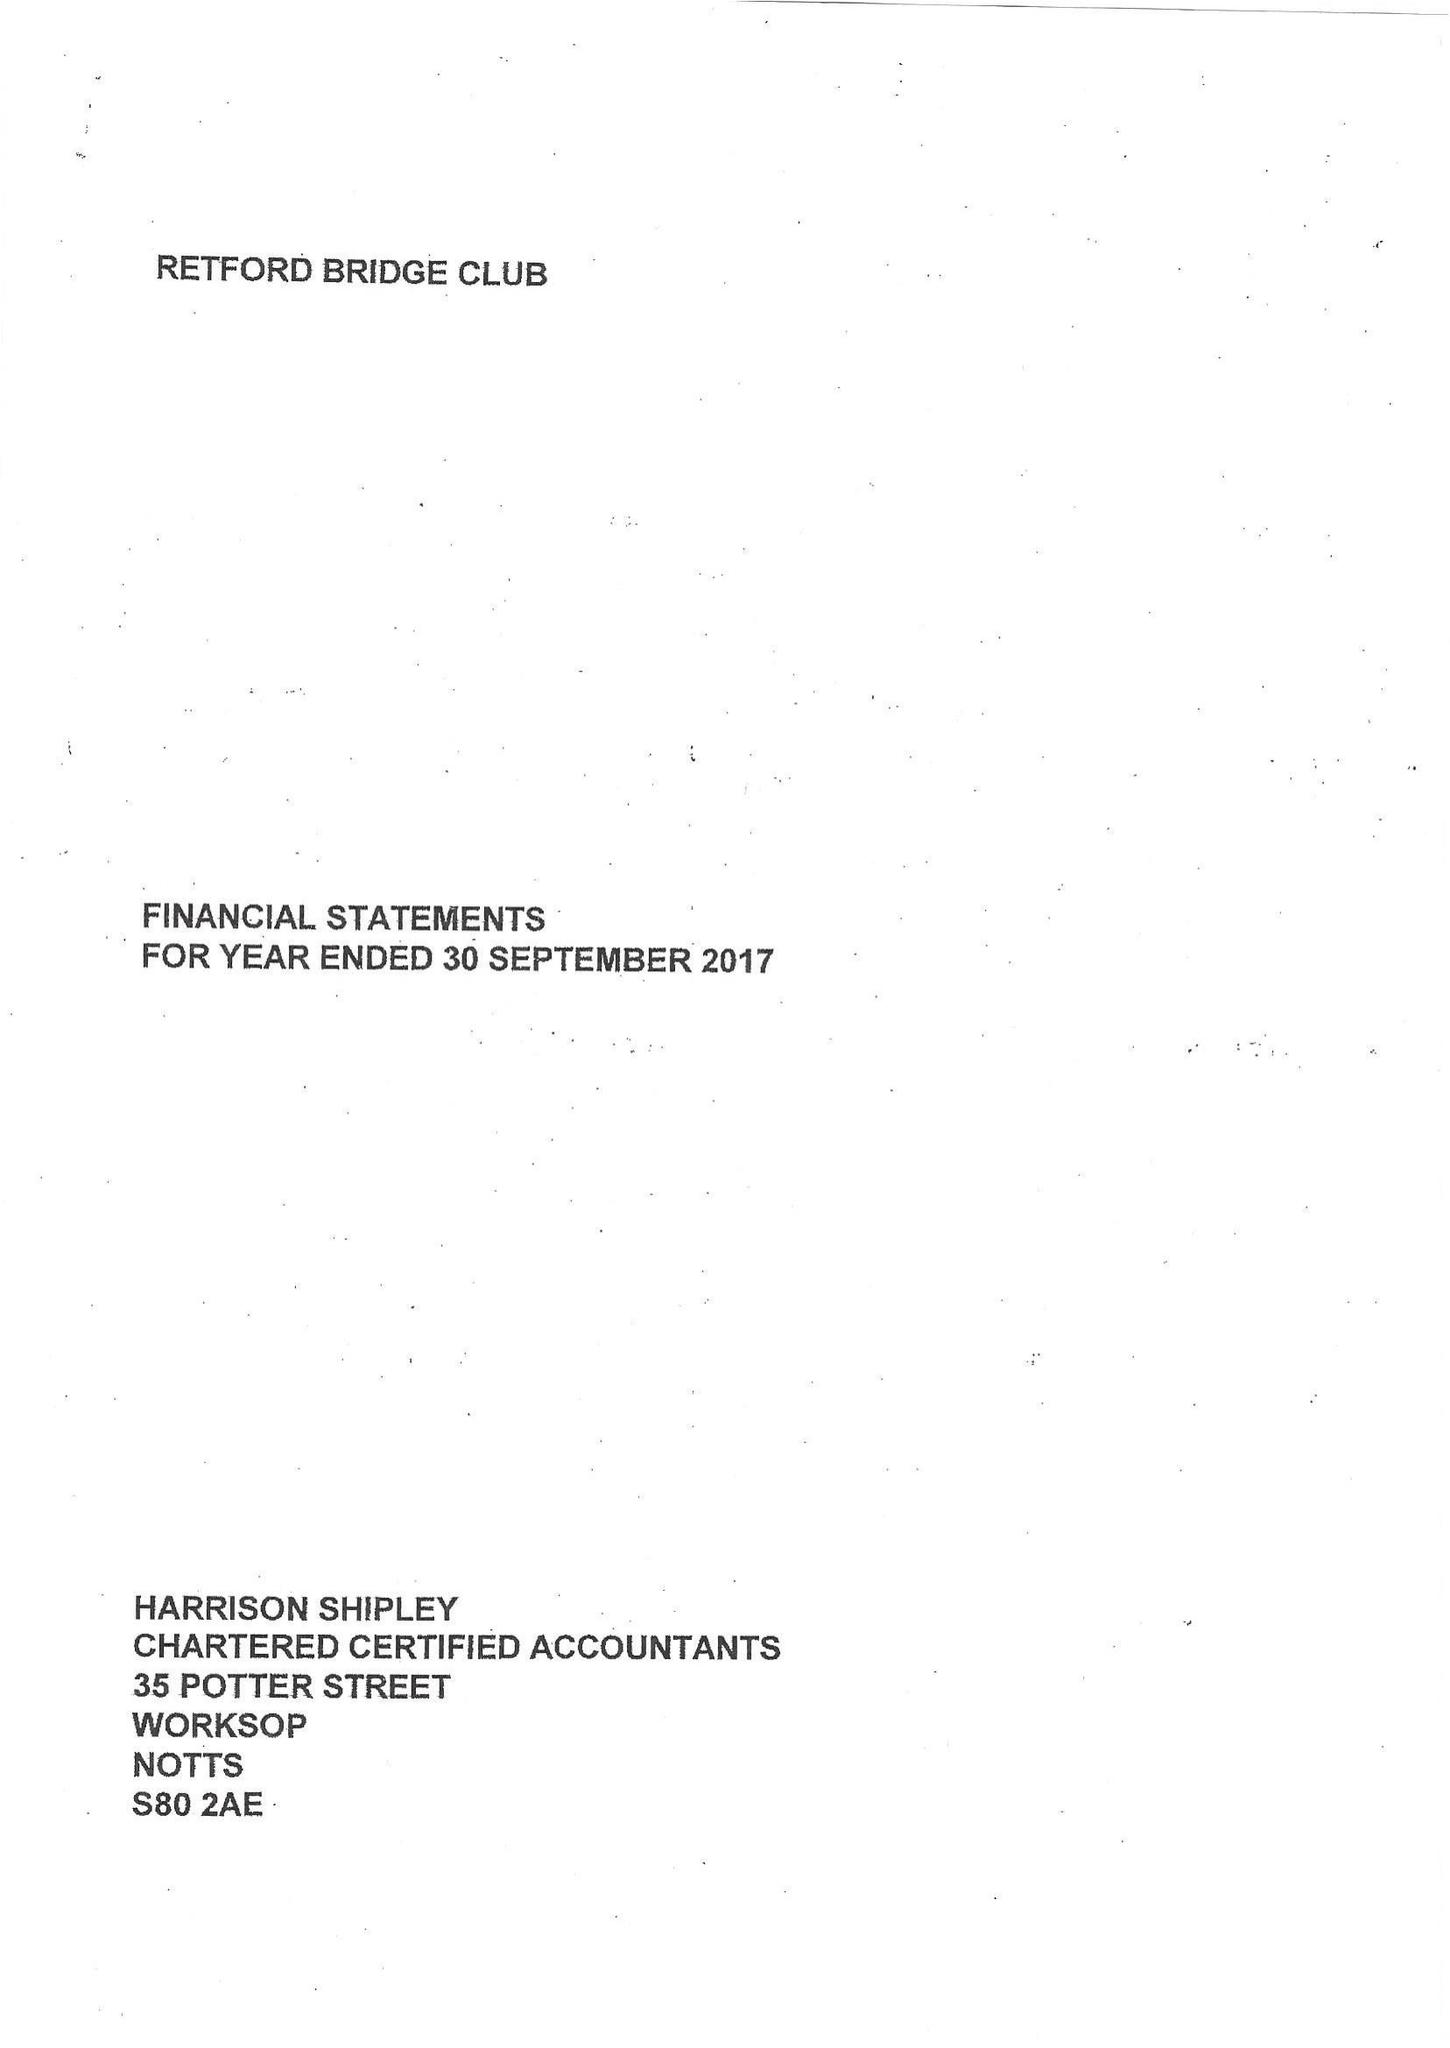What is the value for the spending_annually_in_british_pounds?
Answer the question using a single word or phrase. 7814.00 